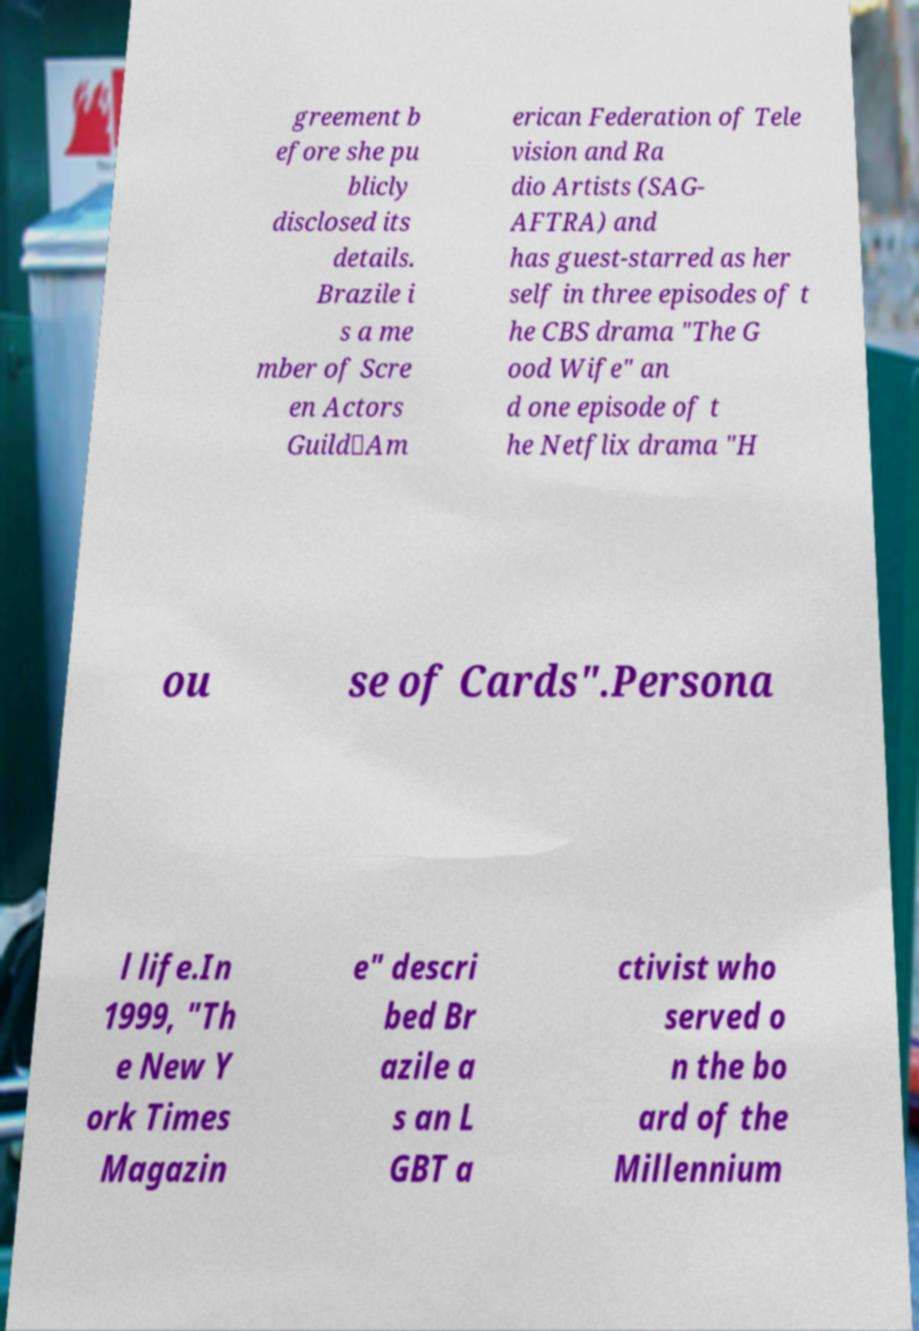Could you assist in decoding the text presented in this image and type it out clearly? greement b efore she pu blicly disclosed its details. Brazile i s a me mber of Scre en Actors Guild‐Am erican Federation of Tele vision and Ra dio Artists (SAG- AFTRA) and has guest-starred as her self in three episodes of t he CBS drama "The G ood Wife" an d one episode of t he Netflix drama "H ou se of Cards".Persona l life.In 1999, "Th e New Y ork Times Magazin e" descri bed Br azile a s an L GBT a ctivist who served o n the bo ard of the Millennium 